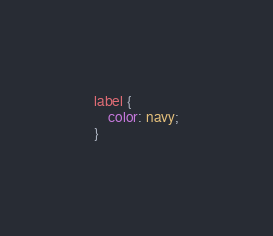<code> <loc_0><loc_0><loc_500><loc_500><_CSS_>
label {
    color: navy;
}</code> 